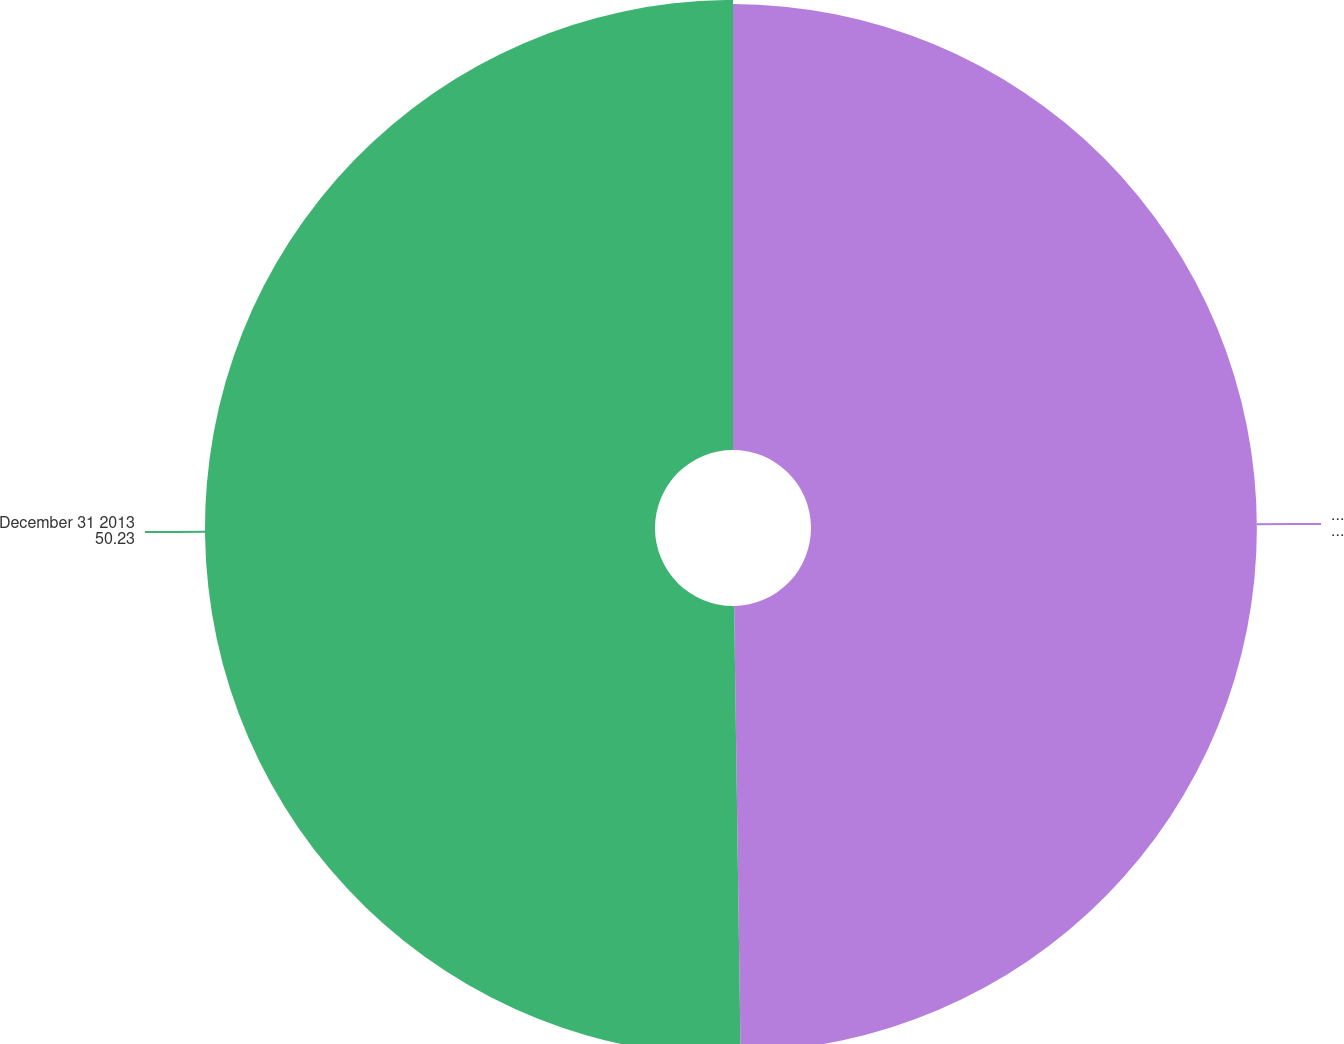<chart> <loc_0><loc_0><loc_500><loc_500><pie_chart><fcel>January 1 2013<fcel>December 31 2013<nl><fcel>49.77%<fcel>50.23%<nl></chart> 